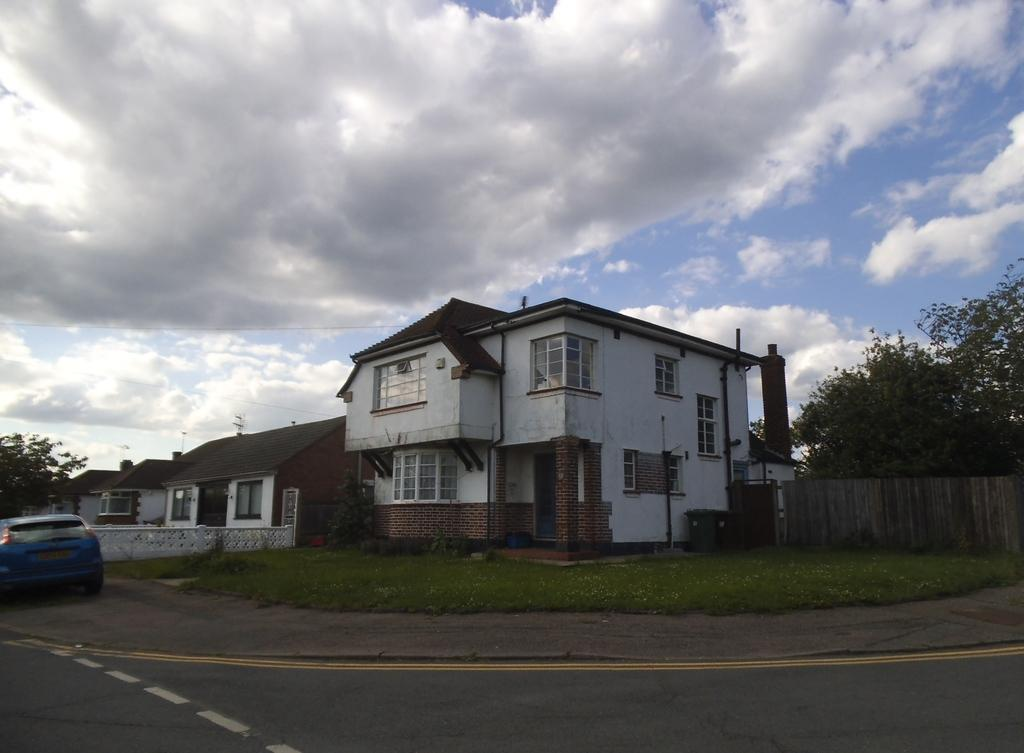What can be seen at the center of the image? There are buildings and trees at the center of the image. What is happening in front of the buildings? There is a car moving on the road in front of the buildings. What can be seen in the background of the image? The sky is visible in the background of the image. Can you hear the lettuce crying in the image? There is no lettuce present in the image, and therefore it cannot be heard crying. 